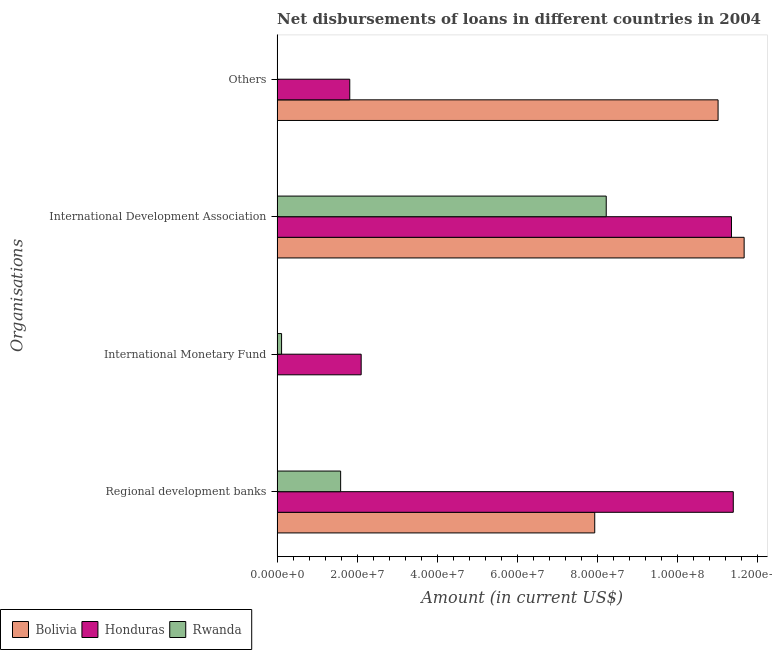How many groups of bars are there?
Provide a succinct answer. 4. Are the number of bars per tick equal to the number of legend labels?
Provide a short and direct response. No. Are the number of bars on each tick of the Y-axis equal?
Give a very brief answer. No. How many bars are there on the 2nd tick from the bottom?
Offer a very short reply. 2. What is the label of the 2nd group of bars from the top?
Give a very brief answer. International Development Association. What is the amount of loan disimbursed by regional development banks in Honduras?
Keep it short and to the point. 1.14e+08. Across all countries, what is the maximum amount of loan disimbursed by regional development banks?
Give a very brief answer. 1.14e+08. Across all countries, what is the minimum amount of loan disimbursed by other organisations?
Give a very brief answer. 0. In which country was the amount of loan disimbursed by regional development banks maximum?
Give a very brief answer. Honduras. What is the total amount of loan disimbursed by regional development banks in the graph?
Your answer should be compact. 2.09e+08. What is the difference between the amount of loan disimbursed by regional development banks in Rwanda and that in Bolivia?
Your answer should be compact. -6.34e+07. What is the difference between the amount of loan disimbursed by international development association in Honduras and the amount of loan disimbursed by other organisations in Rwanda?
Provide a short and direct response. 1.13e+08. What is the average amount of loan disimbursed by other organisations per country?
Provide a short and direct response. 4.27e+07. What is the difference between the amount of loan disimbursed by other organisations and amount of loan disimbursed by international development association in Bolivia?
Make the answer very short. -6.51e+06. In how many countries, is the amount of loan disimbursed by international monetary fund greater than 104000000 US$?
Keep it short and to the point. 0. What is the ratio of the amount of loan disimbursed by regional development banks in Bolivia to that in Honduras?
Make the answer very short. 0.7. What is the difference between the highest and the second highest amount of loan disimbursed by regional development banks?
Provide a succinct answer. 3.46e+07. What is the difference between the highest and the lowest amount of loan disimbursed by international monetary fund?
Offer a very short reply. 2.10e+07. Is the sum of the amount of loan disimbursed by international development association in Rwanda and Bolivia greater than the maximum amount of loan disimbursed by international monetary fund across all countries?
Provide a short and direct response. Yes. Is it the case that in every country, the sum of the amount of loan disimbursed by international monetary fund and amount of loan disimbursed by other organisations is greater than the sum of amount of loan disimbursed by regional development banks and amount of loan disimbursed by international development association?
Give a very brief answer. No. Is it the case that in every country, the sum of the amount of loan disimbursed by regional development banks and amount of loan disimbursed by international monetary fund is greater than the amount of loan disimbursed by international development association?
Your answer should be compact. No. Are all the bars in the graph horizontal?
Your answer should be very brief. Yes. How many countries are there in the graph?
Your answer should be compact. 3. What is the difference between two consecutive major ticks on the X-axis?
Offer a very short reply. 2.00e+07. Are the values on the major ticks of X-axis written in scientific E-notation?
Your answer should be compact. Yes. Does the graph contain any zero values?
Offer a terse response. Yes. What is the title of the graph?
Give a very brief answer. Net disbursements of loans in different countries in 2004. What is the label or title of the X-axis?
Your response must be concise. Amount (in current US$). What is the label or title of the Y-axis?
Offer a terse response. Organisations. What is the Amount (in current US$) of Bolivia in Regional development banks?
Keep it short and to the point. 7.93e+07. What is the Amount (in current US$) of Honduras in Regional development banks?
Ensure brevity in your answer.  1.14e+08. What is the Amount (in current US$) in Rwanda in Regional development banks?
Ensure brevity in your answer.  1.59e+07. What is the Amount (in current US$) of Honduras in International Monetary Fund?
Make the answer very short. 2.10e+07. What is the Amount (in current US$) of Rwanda in International Monetary Fund?
Offer a terse response. 1.11e+06. What is the Amount (in current US$) of Bolivia in International Development Association?
Make the answer very short. 1.17e+08. What is the Amount (in current US$) in Honduras in International Development Association?
Make the answer very short. 1.13e+08. What is the Amount (in current US$) of Rwanda in International Development Association?
Offer a terse response. 8.22e+07. What is the Amount (in current US$) in Bolivia in Others?
Give a very brief answer. 1.10e+08. What is the Amount (in current US$) of Honduras in Others?
Your answer should be compact. 1.81e+07. Across all Organisations, what is the maximum Amount (in current US$) of Bolivia?
Give a very brief answer. 1.17e+08. Across all Organisations, what is the maximum Amount (in current US$) in Honduras?
Your response must be concise. 1.14e+08. Across all Organisations, what is the maximum Amount (in current US$) in Rwanda?
Ensure brevity in your answer.  8.22e+07. Across all Organisations, what is the minimum Amount (in current US$) in Honduras?
Make the answer very short. 1.81e+07. What is the total Amount (in current US$) of Bolivia in the graph?
Ensure brevity in your answer.  3.06e+08. What is the total Amount (in current US$) of Honduras in the graph?
Offer a very short reply. 2.66e+08. What is the total Amount (in current US$) in Rwanda in the graph?
Offer a very short reply. 9.91e+07. What is the difference between the Amount (in current US$) in Honduras in Regional development banks and that in International Monetary Fund?
Make the answer very short. 9.29e+07. What is the difference between the Amount (in current US$) in Rwanda in Regional development banks and that in International Monetary Fund?
Offer a very short reply. 1.47e+07. What is the difference between the Amount (in current US$) in Bolivia in Regional development banks and that in International Development Association?
Keep it short and to the point. -3.73e+07. What is the difference between the Amount (in current US$) of Honduras in Regional development banks and that in International Development Association?
Keep it short and to the point. 4.52e+05. What is the difference between the Amount (in current US$) in Rwanda in Regional development banks and that in International Development Association?
Offer a terse response. -6.63e+07. What is the difference between the Amount (in current US$) of Bolivia in Regional development banks and that in Others?
Make the answer very short. -3.08e+07. What is the difference between the Amount (in current US$) in Honduras in Regional development banks and that in Others?
Make the answer very short. 9.57e+07. What is the difference between the Amount (in current US$) in Honduras in International Monetary Fund and that in International Development Association?
Ensure brevity in your answer.  -9.24e+07. What is the difference between the Amount (in current US$) of Rwanda in International Monetary Fund and that in International Development Association?
Keep it short and to the point. -8.10e+07. What is the difference between the Amount (in current US$) of Honduras in International Monetary Fund and that in Others?
Give a very brief answer. 2.85e+06. What is the difference between the Amount (in current US$) in Bolivia in International Development Association and that in Others?
Offer a very short reply. 6.51e+06. What is the difference between the Amount (in current US$) of Honduras in International Development Association and that in Others?
Your response must be concise. 9.53e+07. What is the difference between the Amount (in current US$) in Bolivia in Regional development banks and the Amount (in current US$) in Honduras in International Monetary Fund?
Give a very brief answer. 5.83e+07. What is the difference between the Amount (in current US$) of Bolivia in Regional development banks and the Amount (in current US$) of Rwanda in International Monetary Fund?
Make the answer very short. 7.82e+07. What is the difference between the Amount (in current US$) of Honduras in Regional development banks and the Amount (in current US$) of Rwanda in International Monetary Fund?
Provide a short and direct response. 1.13e+08. What is the difference between the Amount (in current US$) in Bolivia in Regional development banks and the Amount (in current US$) in Honduras in International Development Association?
Your answer should be compact. -3.41e+07. What is the difference between the Amount (in current US$) of Bolivia in Regional development banks and the Amount (in current US$) of Rwanda in International Development Association?
Offer a terse response. -2.87e+06. What is the difference between the Amount (in current US$) of Honduras in Regional development banks and the Amount (in current US$) of Rwanda in International Development Association?
Give a very brief answer. 3.17e+07. What is the difference between the Amount (in current US$) of Bolivia in Regional development banks and the Amount (in current US$) of Honduras in Others?
Your answer should be compact. 6.11e+07. What is the difference between the Amount (in current US$) of Honduras in International Monetary Fund and the Amount (in current US$) of Rwanda in International Development Association?
Keep it short and to the point. -6.12e+07. What is the difference between the Amount (in current US$) of Bolivia in International Development Association and the Amount (in current US$) of Honduras in Others?
Ensure brevity in your answer.  9.84e+07. What is the average Amount (in current US$) in Bolivia per Organisations?
Your answer should be compact. 7.65e+07. What is the average Amount (in current US$) of Honduras per Organisations?
Your answer should be very brief. 6.66e+07. What is the average Amount (in current US$) in Rwanda per Organisations?
Provide a short and direct response. 2.48e+07. What is the difference between the Amount (in current US$) in Bolivia and Amount (in current US$) in Honduras in Regional development banks?
Your response must be concise. -3.46e+07. What is the difference between the Amount (in current US$) of Bolivia and Amount (in current US$) of Rwanda in Regional development banks?
Your answer should be very brief. 6.34e+07. What is the difference between the Amount (in current US$) in Honduras and Amount (in current US$) in Rwanda in Regional development banks?
Keep it short and to the point. 9.80e+07. What is the difference between the Amount (in current US$) in Honduras and Amount (in current US$) in Rwanda in International Monetary Fund?
Offer a very short reply. 1.99e+07. What is the difference between the Amount (in current US$) in Bolivia and Amount (in current US$) in Honduras in International Development Association?
Your response must be concise. 3.16e+06. What is the difference between the Amount (in current US$) of Bolivia and Amount (in current US$) of Rwanda in International Development Association?
Your answer should be compact. 3.44e+07. What is the difference between the Amount (in current US$) in Honduras and Amount (in current US$) in Rwanda in International Development Association?
Your answer should be very brief. 3.13e+07. What is the difference between the Amount (in current US$) in Bolivia and Amount (in current US$) in Honduras in Others?
Your answer should be very brief. 9.19e+07. What is the ratio of the Amount (in current US$) of Honduras in Regional development banks to that in International Monetary Fund?
Offer a terse response. 5.43. What is the ratio of the Amount (in current US$) of Rwanda in Regional development banks to that in International Monetary Fund?
Your response must be concise. 14.25. What is the ratio of the Amount (in current US$) of Bolivia in Regional development banks to that in International Development Association?
Provide a succinct answer. 0.68. What is the ratio of the Amount (in current US$) of Rwanda in Regional development banks to that in International Development Association?
Your response must be concise. 0.19. What is the ratio of the Amount (in current US$) of Bolivia in Regional development banks to that in Others?
Give a very brief answer. 0.72. What is the ratio of the Amount (in current US$) in Honduras in Regional development banks to that in Others?
Your response must be concise. 6.28. What is the ratio of the Amount (in current US$) in Honduras in International Monetary Fund to that in International Development Association?
Offer a terse response. 0.18. What is the ratio of the Amount (in current US$) in Rwanda in International Monetary Fund to that in International Development Association?
Give a very brief answer. 0.01. What is the ratio of the Amount (in current US$) in Honduras in International Monetary Fund to that in Others?
Your answer should be very brief. 1.16. What is the ratio of the Amount (in current US$) of Bolivia in International Development Association to that in Others?
Your response must be concise. 1.06. What is the ratio of the Amount (in current US$) of Honduras in International Development Association to that in Others?
Your response must be concise. 6.25. What is the difference between the highest and the second highest Amount (in current US$) in Bolivia?
Give a very brief answer. 6.51e+06. What is the difference between the highest and the second highest Amount (in current US$) of Honduras?
Give a very brief answer. 4.52e+05. What is the difference between the highest and the second highest Amount (in current US$) in Rwanda?
Provide a short and direct response. 6.63e+07. What is the difference between the highest and the lowest Amount (in current US$) of Bolivia?
Offer a terse response. 1.17e+08. What is the difference between the highest and the lowest Amount (in current US$) in Honduras?
Your answer should be very brief. 9.57e+07. What is the difference between the highest and the lowest Amount (in current US$) of Rwanda?
Your response must be concise. 8.22e+07. 